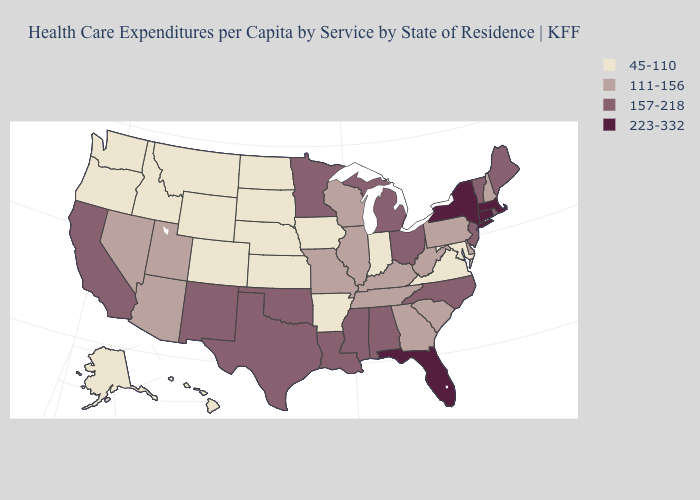What is the value of New Hampshire?
Write a very short answer. 111-156. Name the states that have a value in the range 111-156?
Keep it brief. Arizona, Delaware, Georgia, Illinois, Kentucky, Missouri, Nevada, New Hampshire, Pennsylvania, South Carolina, Tennessee, Utah, West Virginia, Wisconsin. Name the states that have a value in the range 157-218?
Write a very short answer. Alabama, California, Louisiana, Maine, Michigan, Minnesota, Mississippi, New Jersey, New Mexico, North Carolina, Ohio, Oklahoma, Rhode Island, Texas, Vermont. Among the states that border Pennsylvania , which have the highest value?
Give a very brief answer. New York. What is the value of New Jersey?
Answer briefly. 157-218. What is the value of Alaska?
Give a very brief answer. 45-110. Name the states that have a value in the range 45-110?
Concise answer only. Alaska, Arkansas, Colorado, Hawaii, Idaho, Indiana, Iowa, Kansas, Maryland, Montana, Nebraska, North Dakota, Oregon, South Dakota, Virginia, Washington, Wyoming. What is the value of Louisiana?
Answer briefly. 157-218. Does the first symbol in the legend represent the smallest category?
Write a very short answer. Yes. Name the states that have a value in the range 111-156?
Write a very short answer. Arizona, Delaware, Georgia, Illinois, Kentucky, Missouri, Nevada, New Hampshire, Pennsylvania, South Carolina, Tennessee, Utah, West Virginia, Wisconsin. Does Delaware have the same value as Maine?
Be succinct. No. Which states hav the highest value in the Northeast?
Answer briefly. Connecticut, Massachusetts, New York. What is the value of Iowa?
Concise answer only. 45-110. What is the lowest value in the West?
Be succinct. 45-110. What is the lowest value in the Northeast?
Give a very brief answer. 111-156. 